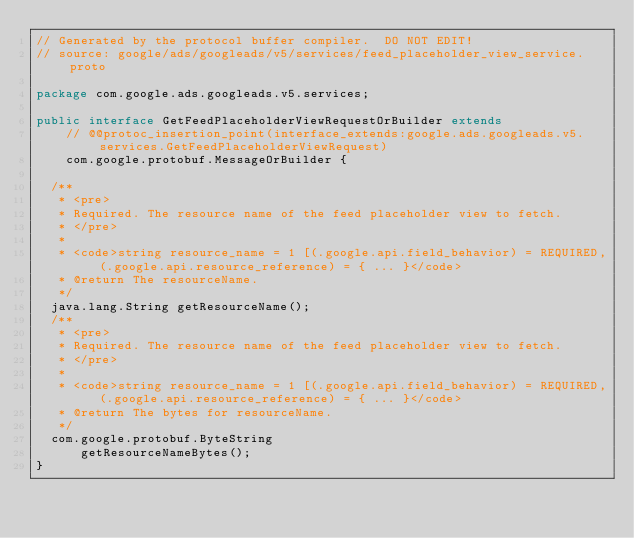Convert code to text. <code><loc_0><loc_0><loc_500><loc_500><_Java_>// Generated by the protocol buffer compiler.  DO NOT EDIT!
// source: google/ads/googleads/v5/services/feed_placeholder_view_service.proto

package com.google.ads.googleads.v5.services;

public interface GetFeedPlaceholderViewRequestOrBuilder extends
    // @@protoc_insertion_point(interface_extends:google.ads.googleads.v5.services.GetFeedPlaceholderViewRequest)
    com.google.protobuf.MessageOrBuilder {

  /**
   * <pre>
   * Required. The resource name of the feed placeholder view to fetch.
   * </pre>
   *
   * <code>string resource_name = 1 [(.google.api.field_behavior) = REQUIRED, (.google.api.resource_reference) = { ... }</code>
   * @return The resourceName.
   */
  java.lang.String getResourceName();
  /**
   * <pre>
   * Required. The resource name of the feed placeholder view to fetch.
   * </pre>
   *
   * <code>string resource_name = 1 [(.google.api.field_behavior) = REQUIRED, (.google.api.resource_reference) = { ... }</code>
   * @return The bytes for resourceName.
   */
  com.google.protobuf.ByteString
      getResourceNameBytes();
}
</code> 